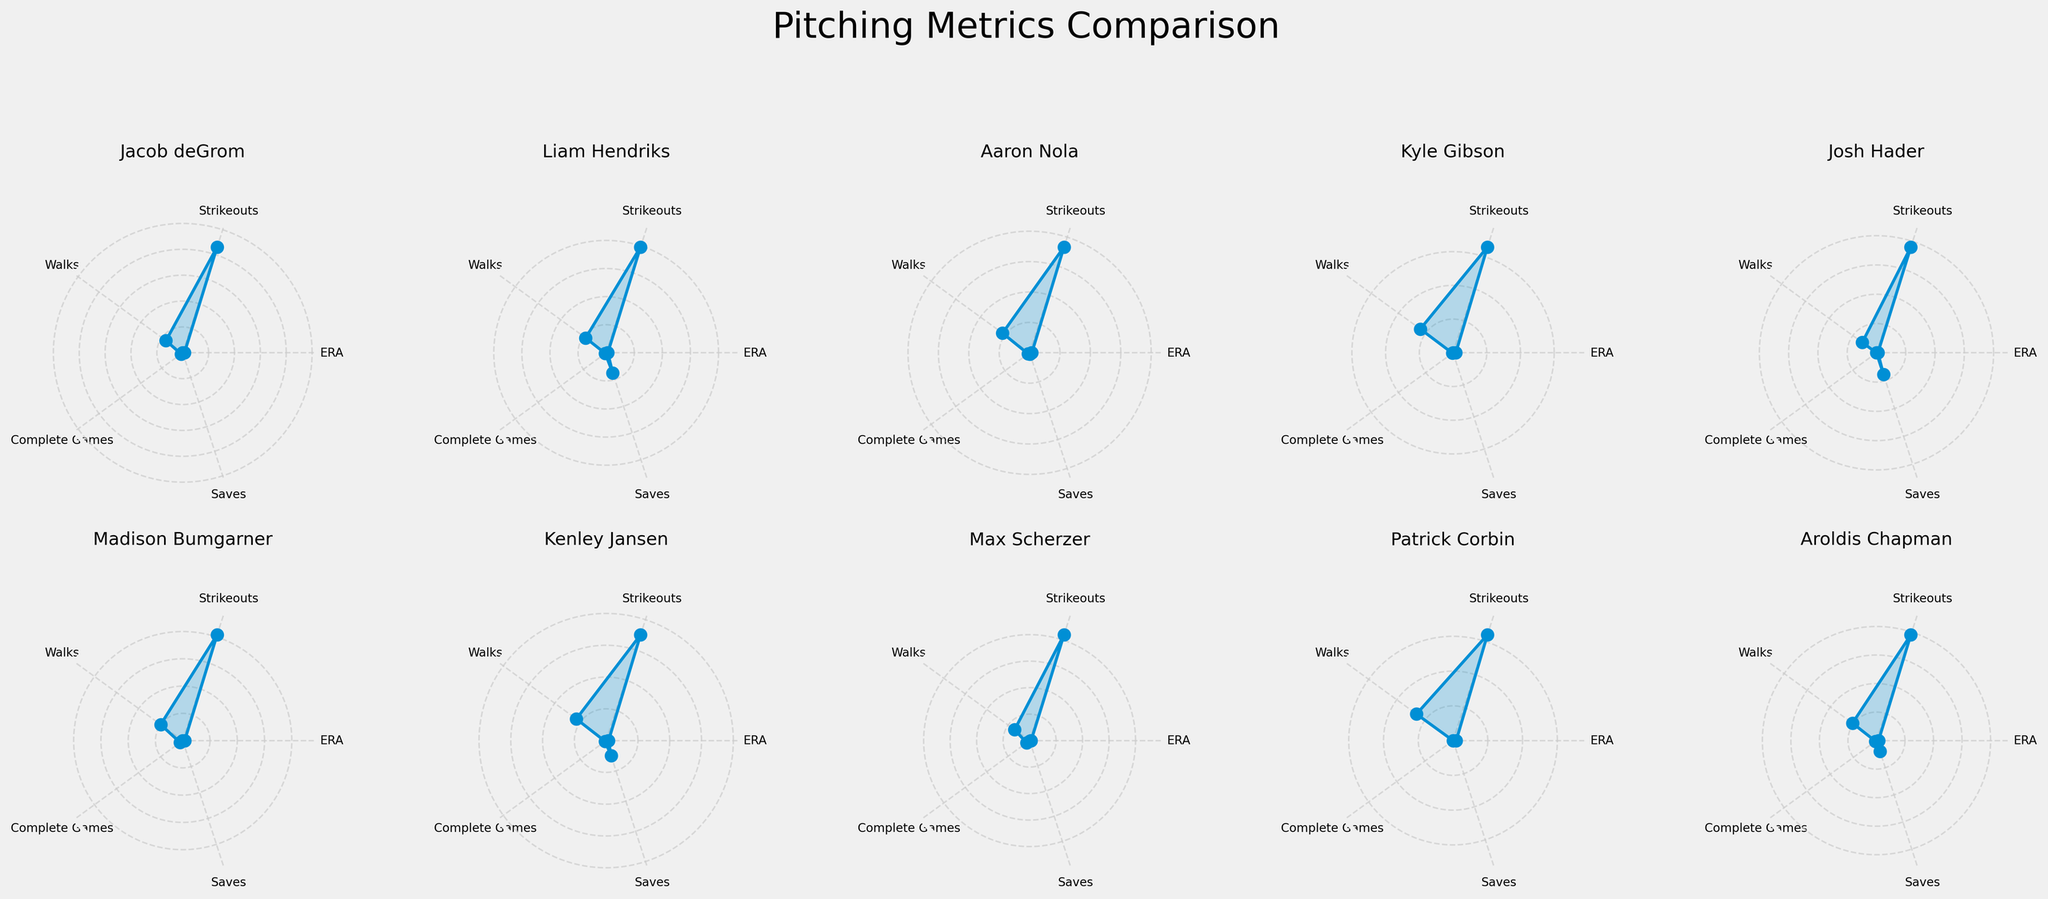What's the title of the figure? The title is usually displayed prominently at the top of the figure. In this case, the title of the figure is "Pitching Metrics Comparison".
Answer: Pitching Metrics Comparison Which player shows the highest value in the 'Saves' category? By examining the 'Saves' category in each radar chart, we can see that the player with the highest value is Josh Hader.
Answer: Josh Hader How many players have a complete games value greater than 5? By inspecting the radar charts, we notice that only Madison Bumgarner and Max Scherzer have complete games values greater than 5.
Answer: 2 Which player has the lowest ERA in the figure? The radar chart that shows the lowest value in the ERA category should be identified. Josh Hader has the lowest ERA with a value of 2.45.
Answer: Josh Hader Compare the Strikeouts between Jacob deGrom and Max Scherzer. Who has more? By comparing the 'Strikeouts' values in their radar charts, Jacob deGrom has 215 strikeouts whereas Max Scherzer has 210 strikeouts. Therefore, Jacob deGrom has more strikeouts.
Answer: Jacob deGrom What is the average ERA of Aaron Nola, Kyle Gibson, and Patrick Corbin? By adding their ERAs (3.67 + 4.10 + 4.50) and dividing by the number of players (3), the average ERA is calculated: (3.67 + 4.10 + 4.50) / 3 = 4.09.
Answer: 4.09 Which player has zero values for Complete Games? By examining the 'Complete Games' values in the radar charts, both Josh Hader and Patrick Corbin have zero values for Complete Games.
Answer: Josh Hader, Patrick Corbin Which player has the greatest difference between Strikeouts and Walks? Calculating the difference between 'Strikeouts' and 'Walks' for each player, Jacob deGrom has the greatest difference with (215 - 40) = 175.
Answer: Jacob deGrom What's the combined value of Saves for Aroldis Chapman and Kenley Jansen? Adding the 'Saves' values for both players, Aroldis Chapman has 20 and Kenley Jansen has 25, so the combined value is 20 + 25 = 45.
Answer: 45 